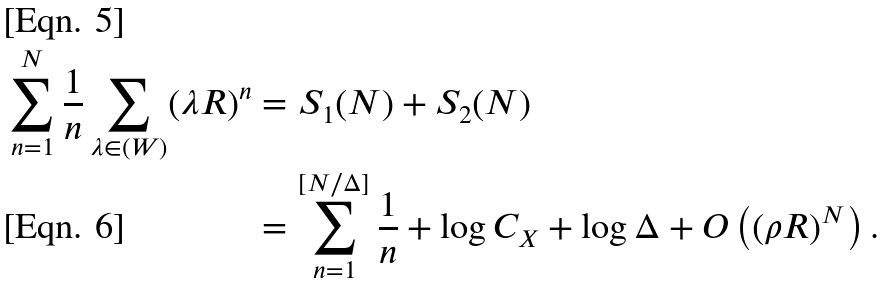Convert formula to latex. <formula><loc_0><loc_0><loc_500><loc_500>\sum _ { n = 1 } ^ { N } \frac { 1 } { n } \sum _ { \lambda \in ( W ) } ( \lambda R ) ^ { n } & = S _ { 1 } ( N ) + S _ { 2 } ( N ) \\ & = \sum _ { n = 1 } ^ { [ { N } / { \Delta } ] } \frac { 1 } { n } + \log C _ { X } + \log \Delta + O \left ( ( \rho R ) ^ { N } \right ) .</formula> 